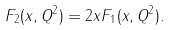Convert formula to latex. <formula><loc_0><loc_0><loc_500><loc_500>F _ { 2 } ( x , Q ^ { 2 } ) = 2 x F _ { 1 } ( x , Q ^ { 2 } ) .</formula> 